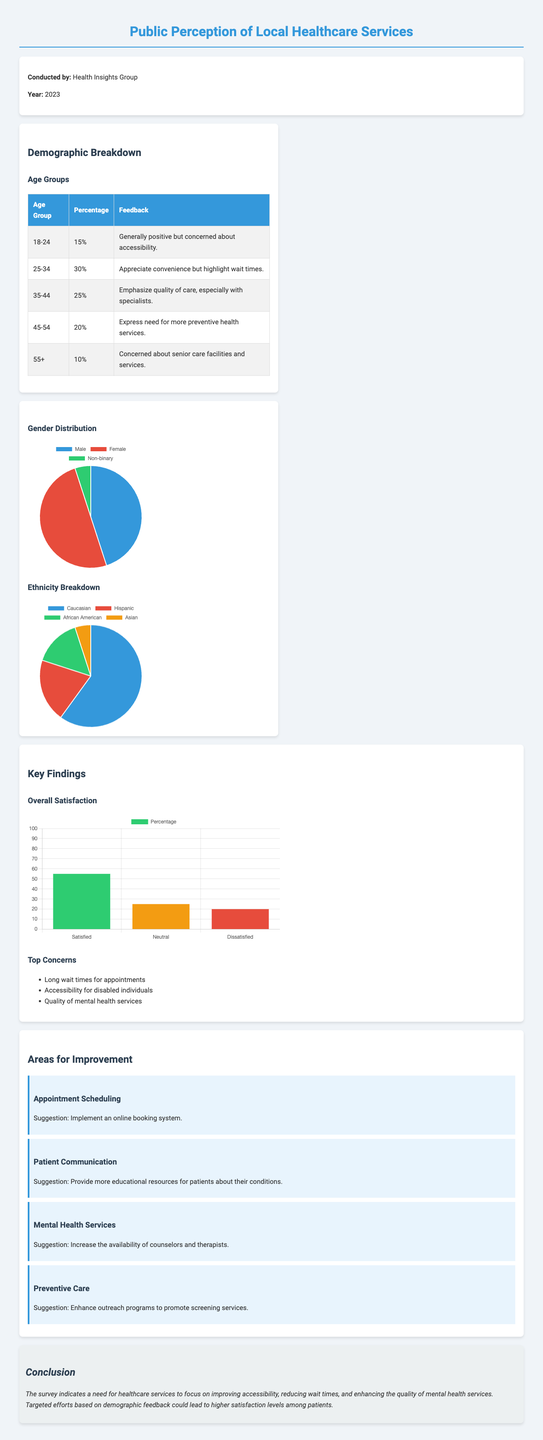what percentage of the survey respondents are in the age group 25-34? The document states that 30% of respondents belong to the age group 25-34.
Answer: 30% what is the primary concern expressed by the 18-24 age group? According to the document, this age group is generally positive but concerned about accessibility.
Answer: Accessibility how many respondents fall under the '55+' age group? The document indicates that 10% of respondents fall in the 55+ age group.
Answer: 10% which demographic group has the highest representation? The document states that the Caucasian demographic has the highest representation at 60%.
Answer: Caucasian what is the suggestion for improving mental health services? The document suggests increasing the availability of counselors and therapists.
Answer: Increase availability of counselors and therapists what overall percentage of respondents expressed satisfaction with healthcare services? The document reports that 55% of respondents are satisfied with healthcare services.
Answer: 55% which demographic has the second-largest feedback percentage? The document indicates that the age group 35-44 has a feedback percentage of 25%, making it the second-largest.
Answer: 25% what are the top three concerns highlighted in the key findings section? The document lists long wait times, accessibility for disabled individuals, and quality of mental health services as top concerns.
Answer: Long wait times, accessibility for disabled individuals, quality of mental health services what improvement suggestion involves online systems? The suggestion is to implement an online booking system for appointment scheduling.
Answer: Implement an online booking system 